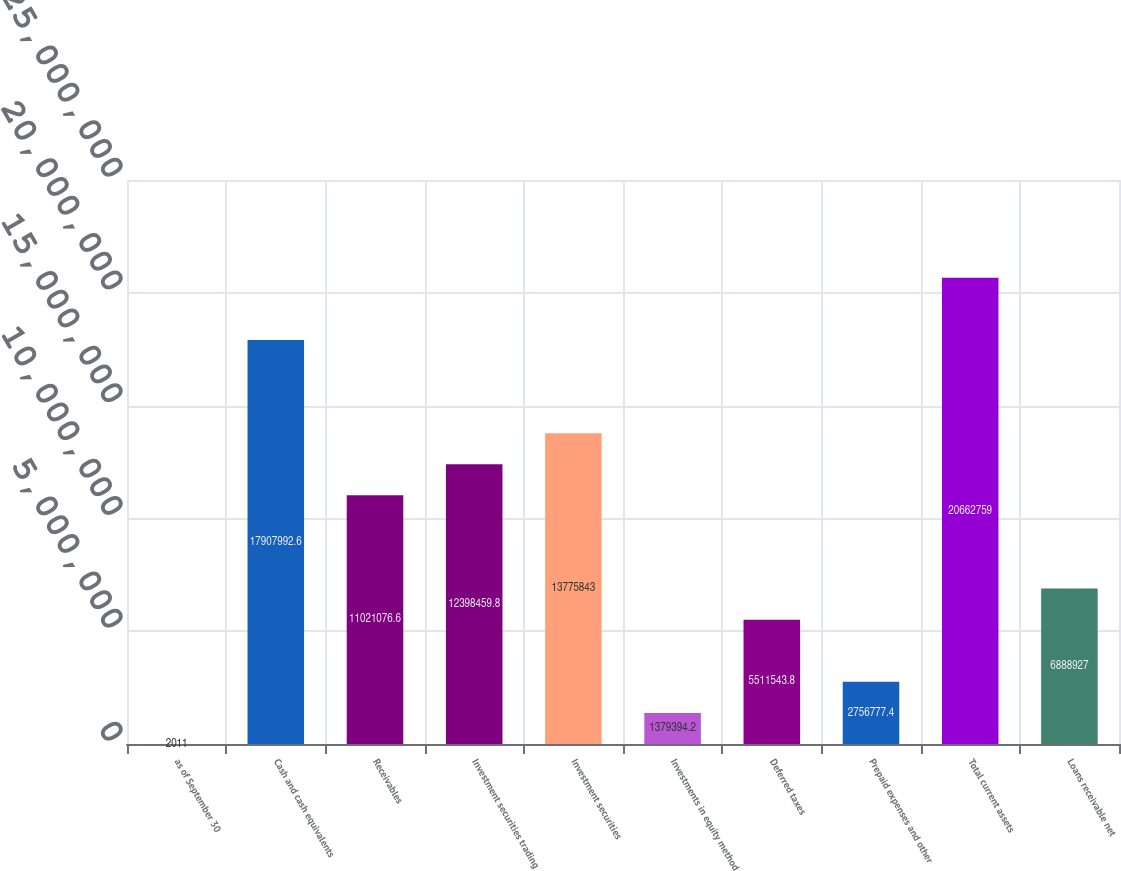Convert chart. <chart><loc_0><loc_0><loc_500><loc_500><bar_chart><fcel>as of September 30<fcel>Cash and cash equivalents<fcel>Receivables<fcel>Investment securities trading<fcel>Investment securities<fcel>Investments in equity method<fcel>Deferred taxes<fcel>Prepaid expenses and other<fcel>Total current assets<fcel>Loans receivable net<nl><fcel>2011<fcel>1.7908e+07<fcel>1.10211e+07<fcel>1.23985e+07<fcel>1.37758e+07<fcel>1.37939e+06<fcel>5.51154e+06<fcel>2.75678e+06<fcel>2.06628e+07<fcel>6.88893e+06<nl></chart> 